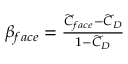Convert formula to latex. <formula><loc_0><loc_0><loc_500><loc_500>\begin{array} { r } { \beta _ { f a c e } = \frac { \widetilde { C } _ { f a c e } - \widetilde { C } _ { D } } { 1 - \widetilde { C } _ { D } } } \end{array}</formula> 